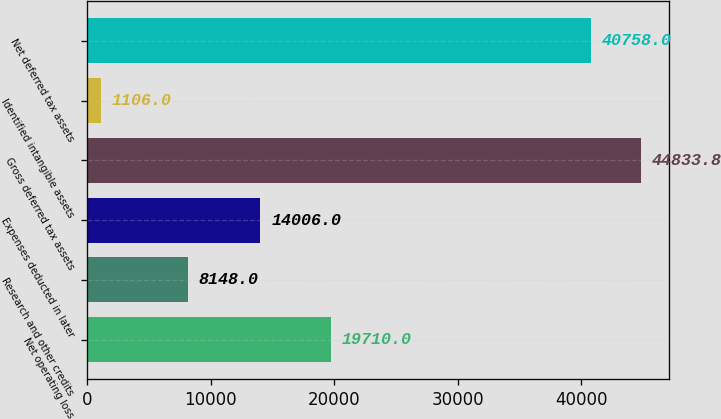Convert chart. <chart><loc_0><loc_0><loc_500><loc_500><bar_chart><fcel>Net operating loss<fcel>Research and other credits<fcel>Expenses deducted in later<fcel>Gross deferred tax assets<fcel>Identified intangible assets<fcel>Net deferred tax assets<nl><fcel>19710<fcel>8148<fcel>14006<fcel>44833.8<fcel>1106<fcel>40758<nl></chart> 